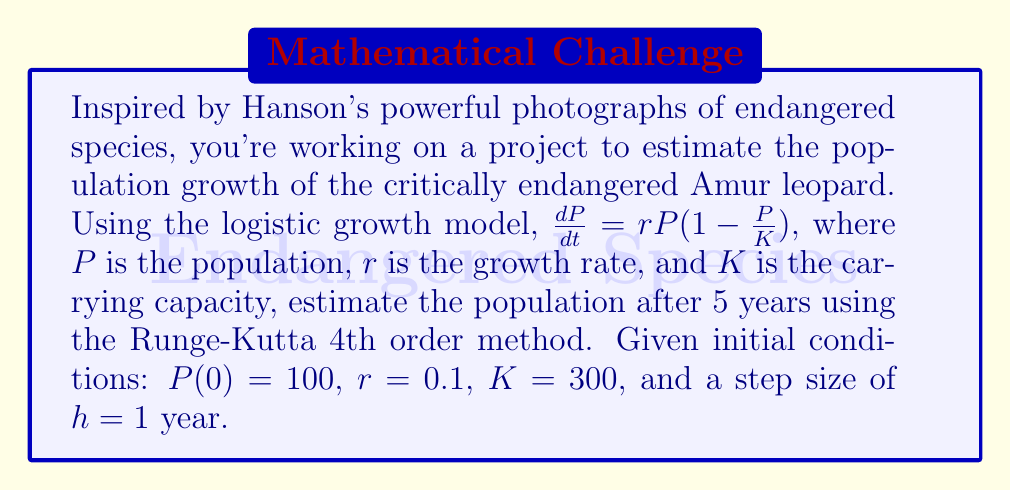Solve this math problem. To solve this problem, we'll use the Runge-Kutta 4th order method (RK4) to numerically approximate the solution to the logistic growth model.

The RK4 method for a first-order ODE $\frac{dy}{dt} = f(t,y)$ is given by:

$$y_{n+1} = y_n + \frac{1}{6}(k_1 + 2k_2 + 2k_3 + k_4)$$

Where:
$$k_1 = hf(t_n, y_n)$$
$$k_2 = hf(t_n + \frac{h}{2}, y_n + \frac{k_1}{2})$$
$$k_3 = hf(t_n + \frac{h}{2}, y_n + \frac{k_2}{2})$$
$$k_4 = hf(t_n + h, y_n + k_3)$$

For our logistic growth model, $f(t,P) = rP(1-\frac{P}{K})$

We'll perform 5 iterations (for 5 years) with $h = 1$:

Iteration 1 ($n = 0$):
$$k_1 = 1 \cdot 0.1 \cdot 100(1-\frac{100}{300}) = 6.6667$$
$$k_2 = 1 \cdot 0.1 \cdot 103.3333(1-\frac{103.3333}{300}) = 6.7244$$
$$k_3 = 1 \cdot 0.1 \cdot 103.3622(1-\frac{103.3622}{300}) = 6.7253$$
$$k_4 = 1 \cdot 0.1 \cdot 106.7253(1-\frac{106.7253}{300}) = 6.7789$$

$$P_1 = 100 + \frac{1}{6}(6.6667 + 2(6.7244) + 2(6.7253) + 6.7789) = 106.7242$$

Iteration 2 ($n = 1$):
$$k_1 = 6.7789$$
$$k_2 = 6.8334$$
$$k_3 = 6.8343$$
$$k_4 = 6.8847$$

$$P_2 = 113.5251$$

Iteration 3 ($n = 2$):
$$P_3 = 120.3941$$

Iteration 4 ($n = 3$):
$$P_4 = 127.3220$$

Iteration 5 ($n = 4$):
$$P_5 = 134.2989$$
Answer: The estimated Amur leopard population after 5 years is approximately 134 individuals. 